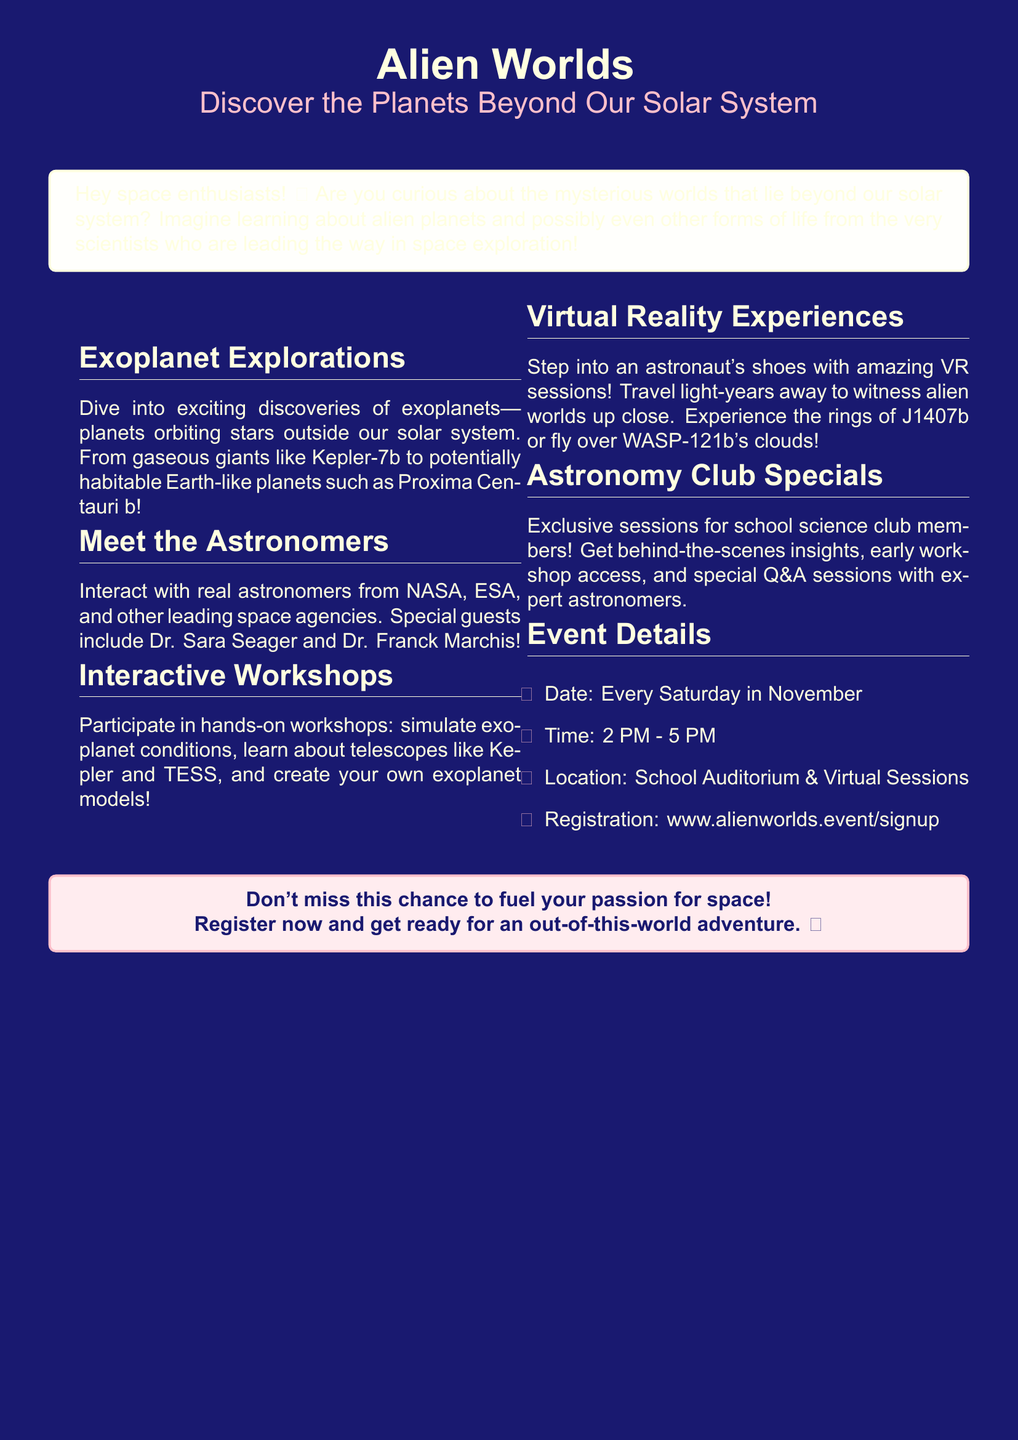What are exoplanets? Exoplanets are defined in the document as planets orbiting stars outside our solar system.
Answer: Planets orbiting stars outside our solar system Who are the special guests? The document mentions Dr. Sara Seager and Dr. Franck Marchis as special guests.
Answer: Dr. Sara Seager and Dr. Franck Marchis When do the events take place? The document states that the events occur every Saturday in November.
Answer: Every Saturday in November What time do the sessions start? The time for the sessions is specified in the document as 2 PM.
Answer: 2 PM What location is mentioned for the sessions? According to the document, the location is the School Auditorium and Virtual Sessions.
Answer: School Auditorium & Virtual Sessions What type of experiences will there be? The document mentions immersive Virtual Reality Experiences as part of the sessions.
Answer: Virtual Reality Experiences What exclusive benefits are offered to Astronomy Club members? The document states they will have exclusive access, insights, and Q&A sessions.
Answer: Behind-the-scenes insights, early workshop access, and special Q&A sessions What will participants learn about in the workshops? Participants will learn about telescopes, simulate exoplanet conditions, and create models.
Answer: Learn about telescopes, simulate conditions, create models What is the registration link? The registration link provided in the document is www.alienworlds.event/signup.
Answer: www.alienworlds.event/signup 